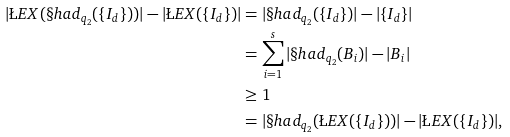Convert formula to latex. <formula><loc_0><loc_0><loc_500><loc_500>| \L E X ( \S h a d _ { q _ { 2 } } ( \{ I _ { d } \} ) ) | - | \L E X ( \{ I _ { d } \} ) | & = | \S h a d _ { q _ { 2 } } ( \{ I _ { d } \} ) | - | \{ I _ { d } \} | \\ & = \sum _ { i = 1 } ^ { s } | \S h a d _ { q _ { 2 } } ( B _ { i } ) | - | B _ { i } | \\ & \geq 1 \\ & = | \S h a d _ { q _ { 2 } } ( \L E X ( \{ I _ { d } \} ) ) | - | \L E X ( \{ I _ { d } \} ) | ,</formula> 